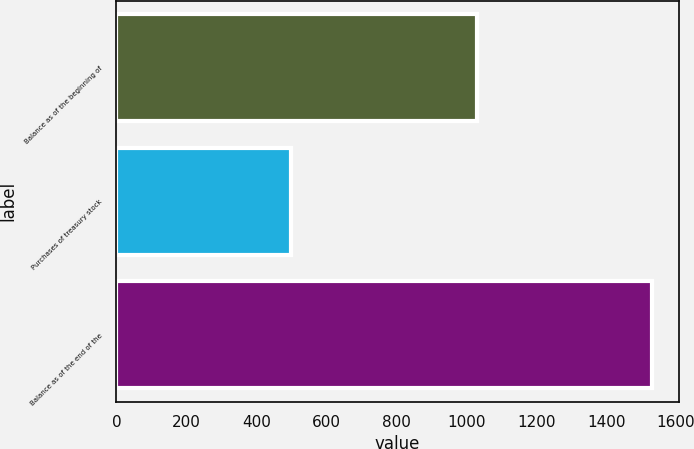<chart> <loc_0><loc_0><loc_500><loc_500><bar_chart><fcel>Balance as of the beginning of<fcel>Purchases of treasury stock<fcel>Balance as of the end of the<nl><fcel>1031<fcel>500<fcel>1531<nl></chart> 